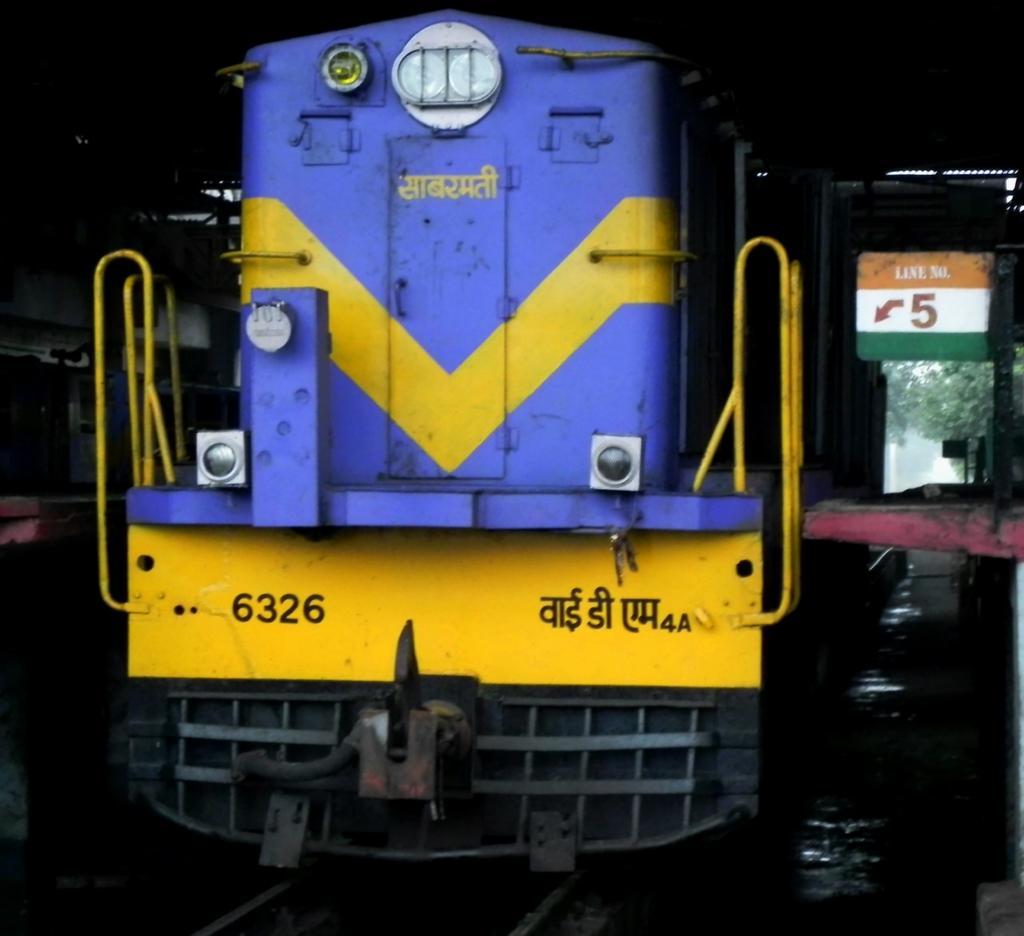Please provide a concise description of this image. In this image I can see the train on the track. To the right I can see the board. In the background I can see the trees. 